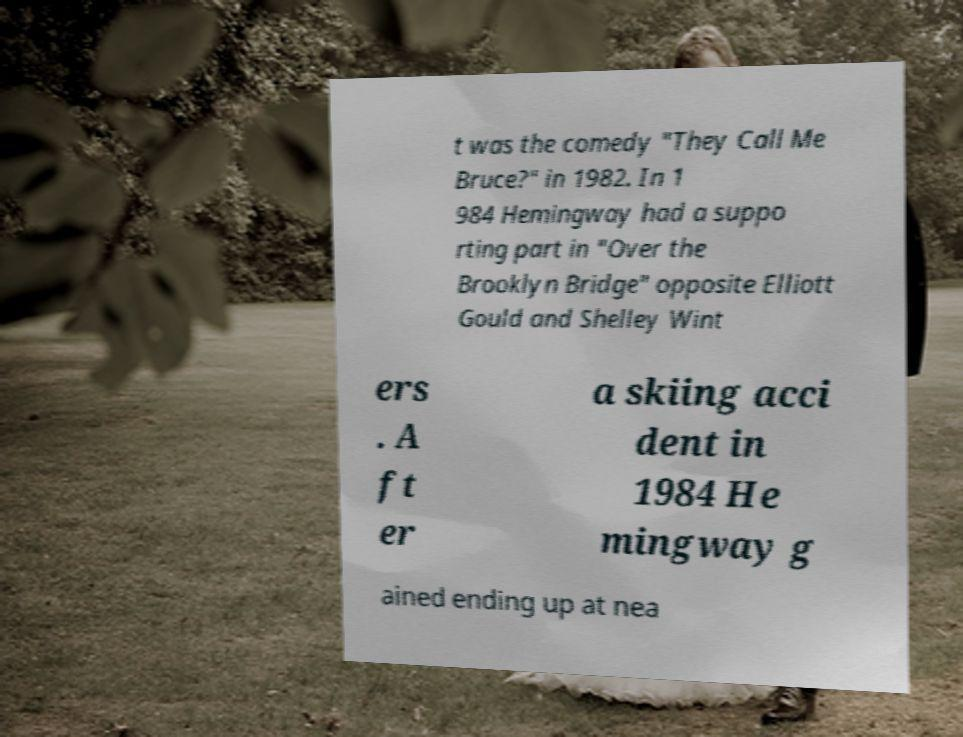Could you assist in decoding the text presented in this image and type it out clearly? t was the comedy "They Call Me Bruce?" in 1982. In 1 984 Hemingway had a suppo rting part in "Over the Brooklyn Bridge" opposite Elliott Gould and Shelley Wint ers . A ft er a skiing acci dent in 1984 He mingway g ained ending up at nea 